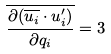<formula> <loc_0><loc_0><loc_500><loc_500>\overline { \frac { \partial ( \overline { u _ { i } } \cdot u _ { i } ^ { \prime } ) } { \partial q _ { i } } } = 3</formula> 